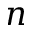<formula> <loc_0><loc_0><loc_500><loc_500>n</formula> 